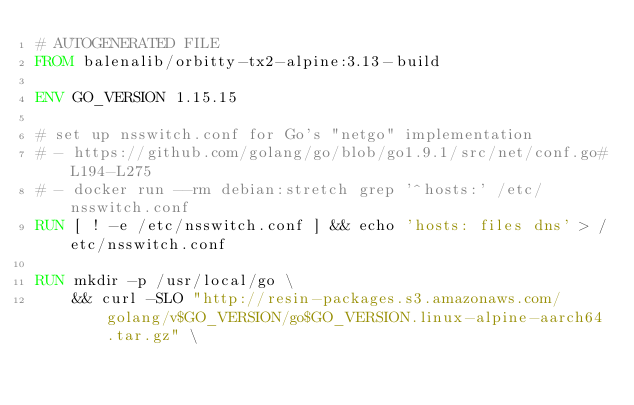Convert code to text. <code><loc_0><loc_0><loc_500><loc_500><_Dockerfile_># AUTOGENERATED FILE
FROM balenalib/orbitty-tx2-alpine:3.13-build

ENV GO_VERSION 1.15.15

# set up nsswitch.conf for Go's "netgo" implementation
# - https://github.com/golang/go/blob/go1.9.1/src/net/conf.go#L194-L275
# - docker run --rm debian:stretch grep '^hosts:' /etc/nsswitch.conf
RUN [ ! -e /etc/nsswitch.conf ] && echo 'hosts: files dns' > /etc/nsswitch.conf

RUN mkdir -p /usr/local/go \
	&& curl -SLO "http://resin-packages.s3.amazonaws.com/golang/v$GO_VERSION/go$GO_VERSION.linux-alpine-aarch64.tar.gz" \</code> 